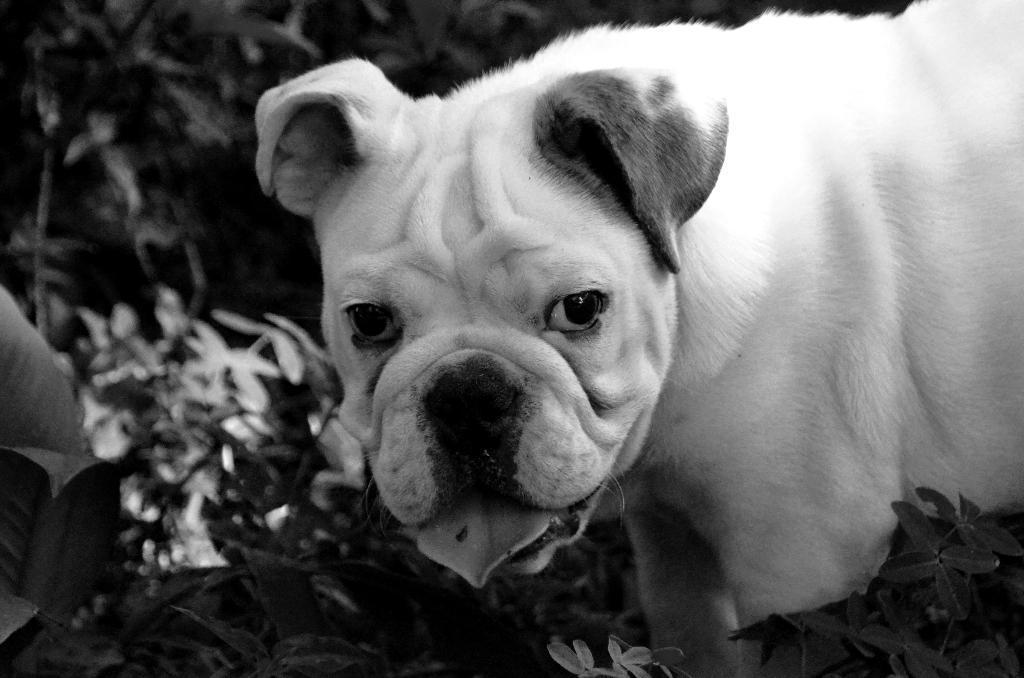How would you summarize this image in a sentence or two? This is a black and white image. In this image we can see a dog. Also there are plants. In the background it is blurred. 